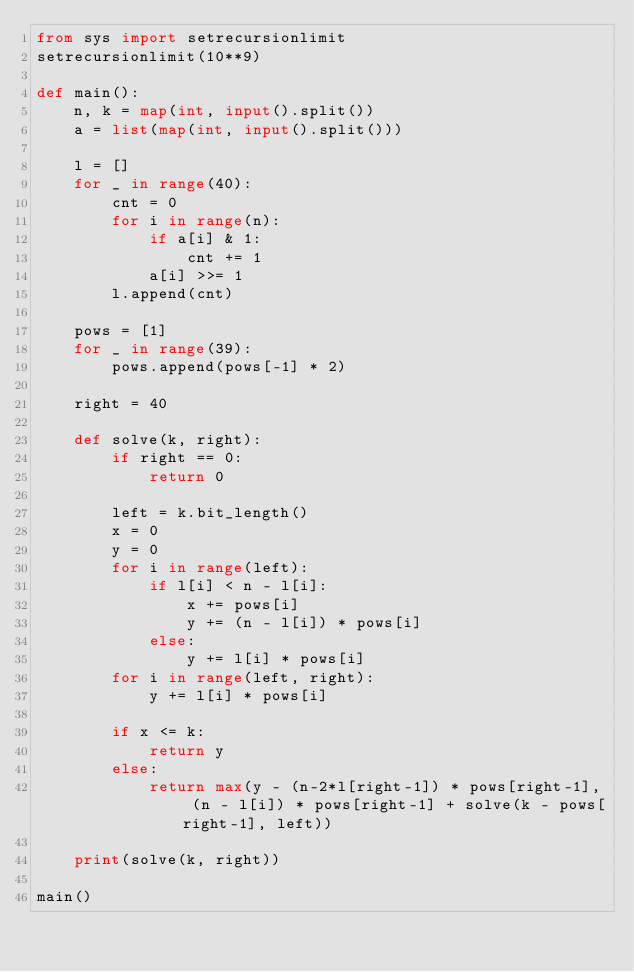<code> <loc_0><loc_0><loc_500><loc_500><_Python_>from sys import setrecursionlimit
setrecursionlimit(10**9)

def main():
    n, k = map(int, input().split())
    a = list(map(int, input().split()))

    l = []
    for _ in range(40):
        cnt = 0
        for i in range(n):
            if a[i] & 1:
                cnt += 1
            a[i] >>= 1
        l.append(cnt)

    pows = [1]
    for _ in range(39):
        pows.append(pows[-1] * 2)

    right = 40

    def solve(k, right):
        if right == 0:
            return 0

        left = k.bit_length()
        x = 0
        y = 0
        for i in range(left):
            if l[i] < n - l[i]:
                x += pows[i]
                y += (n - l[i]) * pows[i]
            else:
                y += l[i] * pows[i]
        for i in range(left, right):
            y += l[i] * pows[i]

        if x <= k:
            return y
        else:
            return max(y - (n-2*l[right-1]) * pows[right-1], (n - l[i]) * pows[right-1] + solve(k - pows[right-1], left))

    print(solve(k, right))

main()</code> 